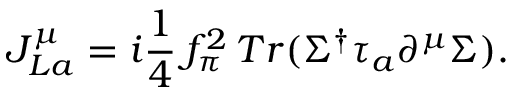Convert formula to latex. <formula><loc_0><loc_0><loc_500><loc_500>J _ { L a } ^ { \mu } = i { \frac { 1 } { 4 } } \, f _ { \pi } ^ { 2 } \, T r ( \Sigma ^ { \dagger } \tau _ { a } \partial ^ { \mu } \Sigma ) .</formula> 